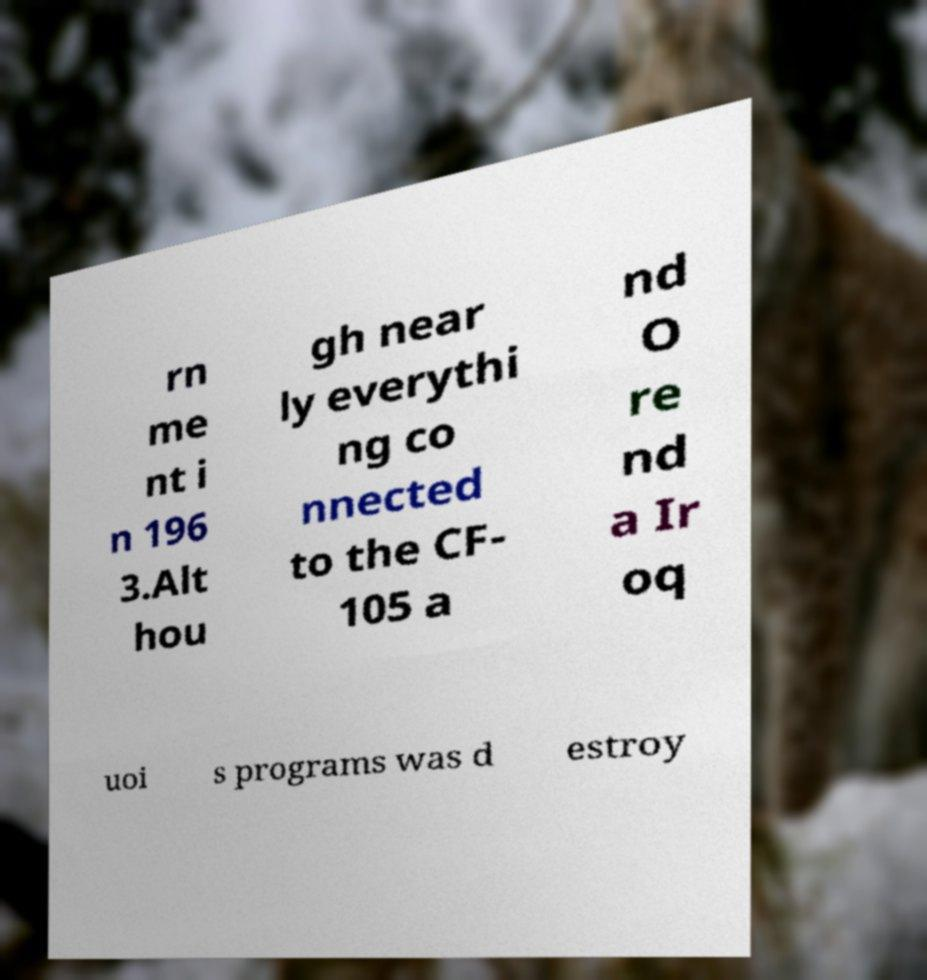Could you assist in decoding the text presented in this image and type it out clearly? rn me nt i n 196 3.Alt hou gh near ly everythi ng co nnected to the CF- 105 a nd O re nd a Ir oq uoi s programs was d estroy 